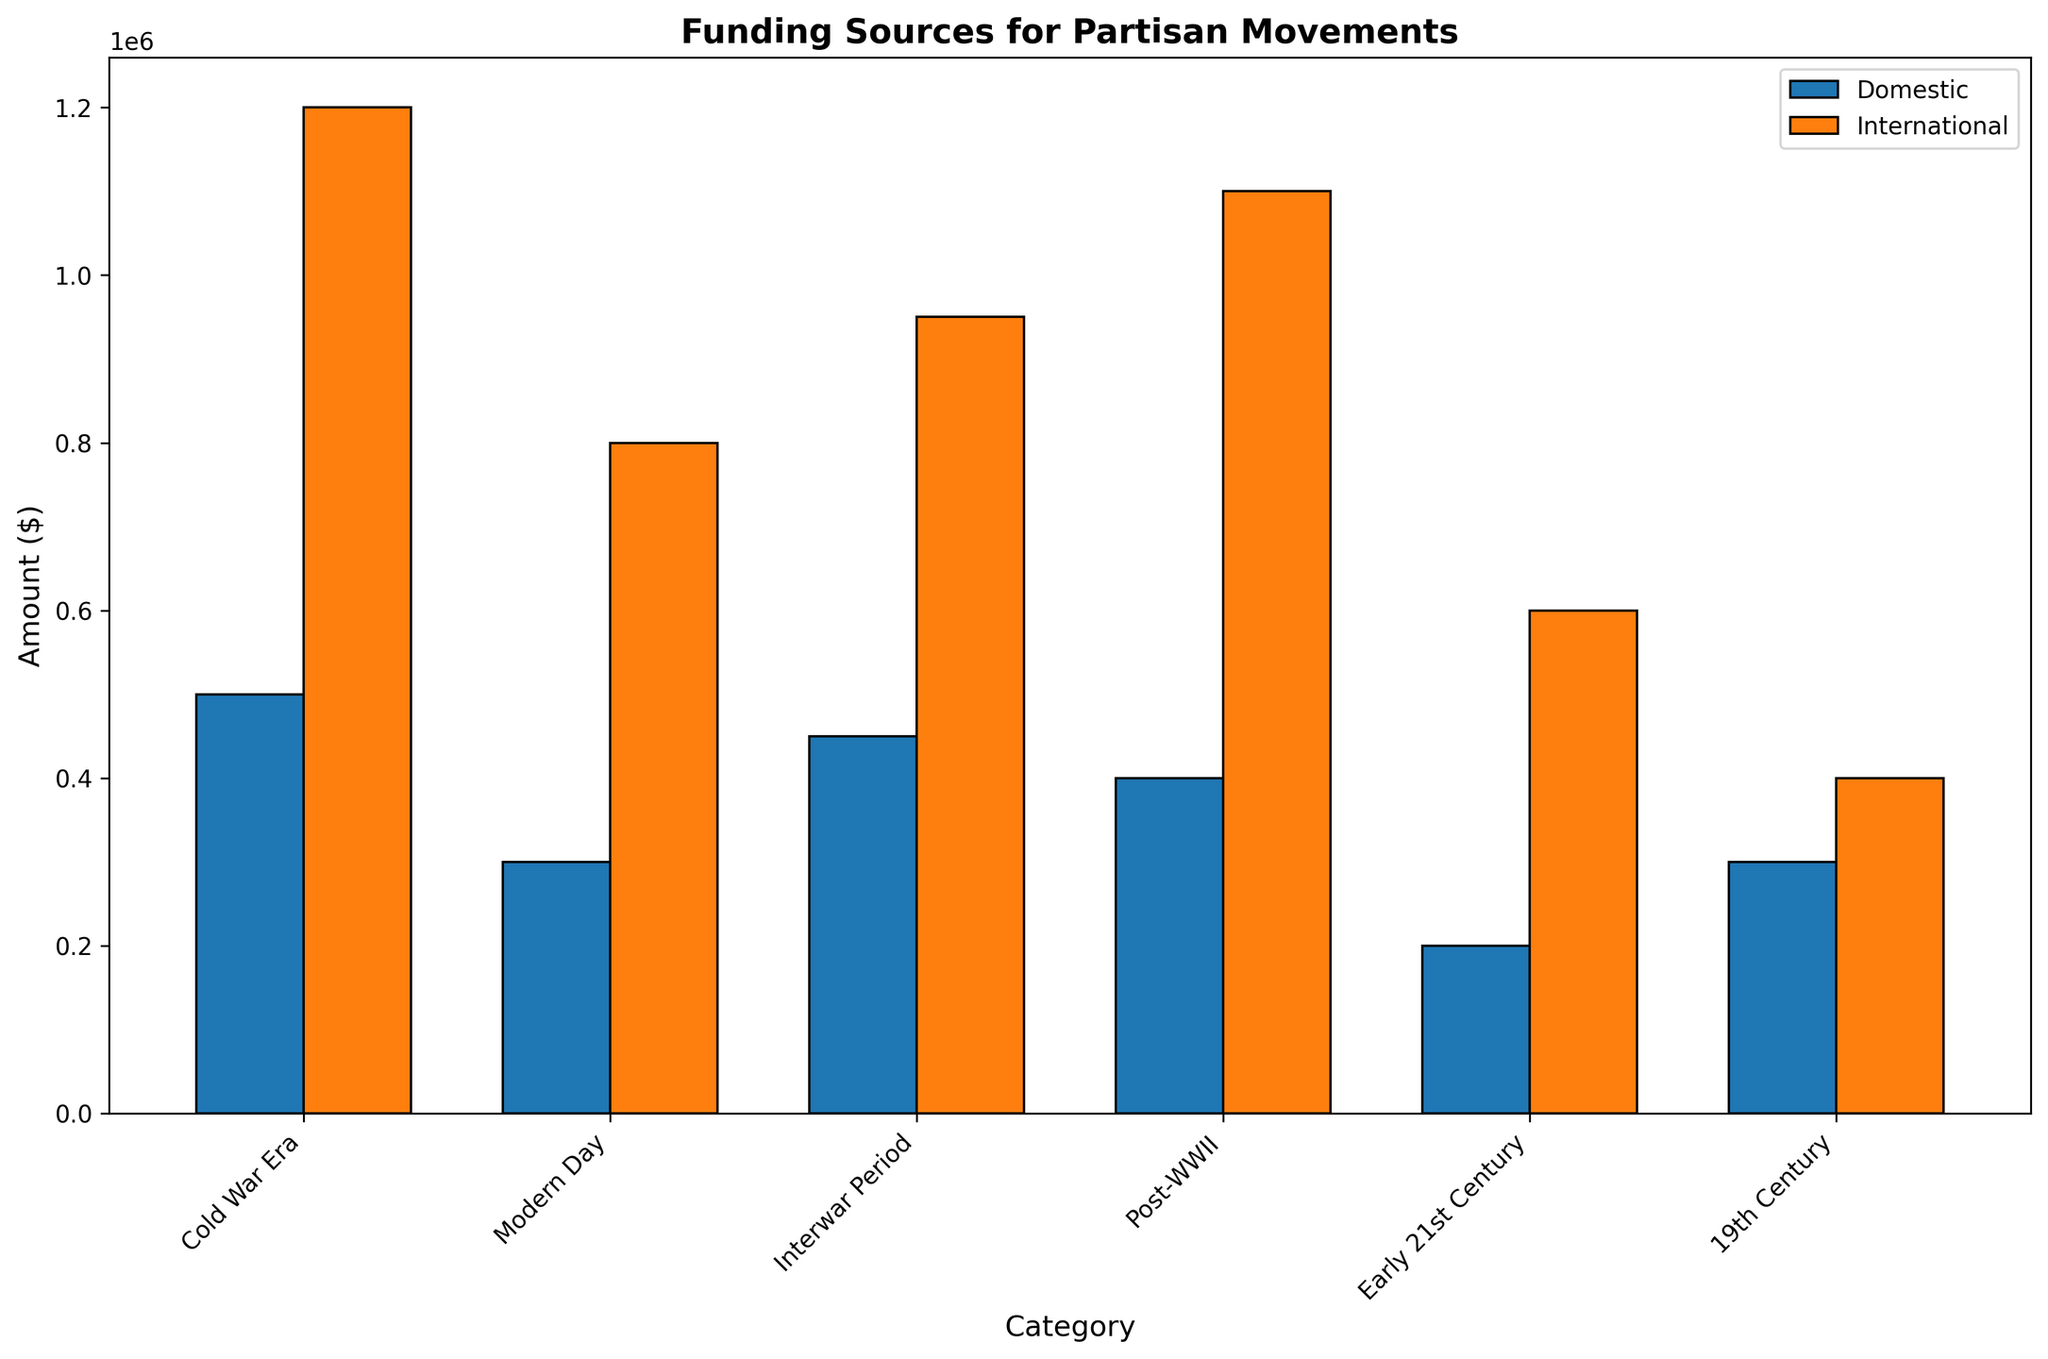Which category has the highest amount of international funding? Observe the heights of the orange bars representing international funding across all categories. The highest bar corresponds to the Cold War Era.
Answer: Cold War Era How does the domestic funding in the Interwar Period compare to the Early 21st Century? Compare the heights of the blue bars representing domestic funding for these two categories. The Interwar Period has a domestic funding of 450,000, while the Early 21st Century has 200,000. Therefore, the Interwar Period has higher domestic funding.
Answer: Interwar Period has higher domestic funding Which category has the smallest difference between domestic and international contributions? Calculate the difference between domestic and international contributions for each category. 19th Century has the smallest difference:
Answer: 19th Century What is the total funding for the Post-WWII category from both domestic and international sources? Sum the domestic funding and international funding for the Post-WWII category. Domestic (400,000) + International (1,100,000) = 1,500,000.
Answer: 1,500,000 In which category is domestic funding closest to international funding? Find the categories where the heights of the blue and orange bars are closest. In the Interwar Period, domestic funding is 450,000 and international funding is 950,000, which are the closest compared to other categories.
Answer: Interwar Period How much more international funding is there compared to domestic funding in the Modern Day category? Subtract the domestic funding amount from the international funding amount for Modern Day. International (800,000) - Domestic (300,000) = 500,000.
Answer: 500,000 Which category has the lowest domestic funding? Observe the heights of the blue bars representing domestic funding across all categories. The Early 21st Century has the lowest at 200,000.
Answer: Early 21st Century What is the average amount of domestic funding across all categories? Sum all domestic funding amounts and divide by the number of categories. (500,000 + 300,000 + 450,000 + 400,000 + 200,000 + 300,000) / 6 = 2,150,000 / 6 ≈ 358,333.
Answer: 358,333 Compare the total funding (both domestic and international) between Cold War Era and Modern Day. Which is greater? Calculate the total funding for each category and compare. Cold War Era (500,000 + 1,200,000 = 1,700,000) and Modern Day (300,000 + 800,000 = 1,100,000). Cold War Era has greater total funding.
Answer: Cold War Era What is the visual difference in the representation of domestic funding for 19th Century and Early 21st Century? Compare the heights and positioning of the blue bars for these two categories. Both bars are of equal height, indicating equal funding amount of 300,000.
Answer: They are equal in height 